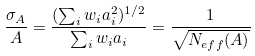Convert formula to latex. <formula><loc_0><loc_0><loc_500><loc_500>\frac { \sigma _ { A } } { A } = \frac { ( \sum _ { i } w _ { i } a _ { i } ^ { 2 } ) ^ { 1 / 2 } } { \sum _ { i } w _ { i } a _ { i } } = \frac { 1 } { \sqrt { N _ { e f f } ( A ) } }</formula> 